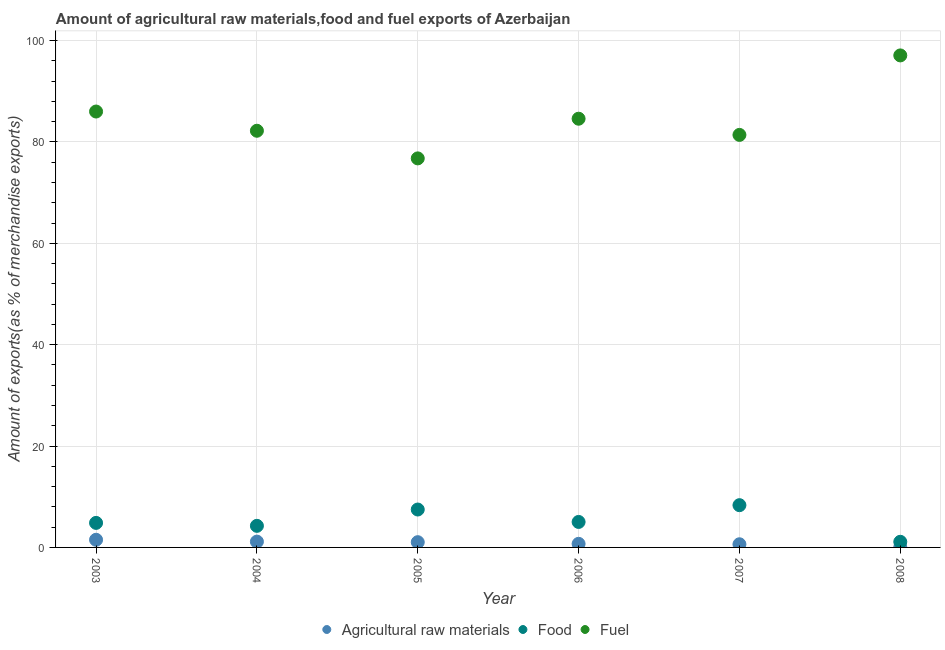Is the number of dotlines equal to the number of legend labels?
Make the answer very short. Yes. What is the percentage of raw materials exports in 2006?
Your answer should be compact. 0.71. Across all years, what is the maximum percentage of raw materials exports?
Keep it short and to the point. 1.51. Across all years, what is the minimum percentage of fuel exports?
Offer a very short reply. 76.76. In which year was the percentage of food exports maximum?
Your response must be concise. 2007. In which year was the percentage of raw materials exports minimum?
Your answer should be compact. 2008. What is the total percentage of fuel exports in the graph?
Give a very brief answer. 508.06. What is the difference between the percentage of fuel exports in 2003 and that in 2004?
Provide a short and direct response. 3.79. What is the difference between the percentage of food exports in 2007 and the percentage of fuel exports in 2008?
Your response must be concise. -88.75. What is the average percentage of food exports per year?
Your answer should be very brief. 5.18. In the year 2004, what is the difference between the percentage of fuel exports and percentage of food exports?
Your response must be concise. 77.96. In how many years, is the percentage of food exports greater than 40 %?
Make the answer very short. 0. What is the ratio of the percentage of raw materials exports in 2006 to that in 2008?
Keep it short and to the point. 16.55. Is the difference between the percentage of fuel exports in 2006 and 2008 greater than the difference between the percentage of raw materials exports in 2006 and 2008?
Offer a very short reply. No. What is the difference between the highest and the second highest percentage of raw materials exports?
Give a very brief answer. 0.36. What is the difference between the highest and the lowest percentage of food exports?
Ensure brevity in your answer.  7.23. Is the sum of the percentage of raw materials exports in 2004 and 2008 greater than the maximum percentage of food exports across all years?
Your answer should be compact. No. Is it the case that in every year, the sum of the percentage of raw materials exports and percentage of food exports is greater than the percentage of fuel exports?
Offer a terse response. No. Does the percentage of raw materials exports monotonically increase over the years?
Provide a short and direct response. No. Is the percentage of fuel exports strictly less than the percentage of food exports over the years?
Offer a terse response. No. How many dotlines are there?
Give a very brief answer. 3. How many years are there in the graph?
Your response must be concise. 6. Does the graph contain any zero values?
Give a very brief answer. No. How are the legend labels stacked?
Ensure brevity in your answer.  Horizontal. What is the title of the graph?
Provide a short and direct response. Amount of agricultural raw materials,food and fuel exports of Azerbaijan. Does "Refusal of sex" appear as one of the legend labels in the graph?
Your response must be concise. No. What is the label or title of the Y-axis?
Provide a succinct answer. Amount of exports(as % of merchandise exports). What is the Amount of exports(as % of merchandise exports) of Agricultural raw materials in 2003?
Offer a very short reply. 1.51. What is the Amount of exports(as % of merchandise exports) of Food in 2003?
Your response must be concise. 4.84. What is the Amount of exports(as % of merchandise exports) in Fuel in 2003?
Offer a very short reply. 86.01. What is the Amount of exports(as % of merchandise exports) in Agricultural raw materials in 2004?
Provide a succinct answer. 1.15. What is the Amount of exports(as % of merchandise exports) of Food in 2004?
Ensure brevity in your answer.  4.26. What is the Amount of exports(as % of merchandise exports) in Fuel in 2004?
Offer a terse response. 82.22. What is the Amount of exports(as % of merchandise exports) in Agricultural raw materials in 2005?
Your answer should be very brief. 1.03. What is the Amount of exports(as % of merchandise exports) in Food in 2005?
Offer a very short reply. 7.48. What is the Amount of exports(as % of merchandise exports) of Fuel in 2005?
Offer a terse response. 76.76. What is the Amount of exports(as % of merchandise exports) of Agricultural raw materials in 2006?
Your response must be concise. 0.71. What is the Amount of exports(as % of merchandise exports) in Food in 2006?
Your answer should be very brief. 5.03. What is the Amount of exports(as % of merchandise exports) in Fuel in 2006?
Your response must be concise. 84.59. What is the Amount of exports(as % of merchandise exports) of Agricultural raw materials in 2007?
Your answer should be compact. 0.62. What is the Amount of exports(as % of merchandise exports) in Food in 2007?
Provide a short and direct response. 8.34. What is the Amount of exports(as % of merchandise exports) in Fuel in 2007?
Keep it short and to the point. 81.4. What is the Amount of exports(as % of merchandise exports) of Agricultural raw materials in 2008?
Your answer should be very brief. 0.04. What is the Amount of exports(as % of merchandise exports) in Food in 2008?
Your response must be concise. 1.11. What is the Amount of exports(as % of merchandise exports) of Fuel in 2008?
Offer a terse response. 97.08. Across all years, what is the maximum Amount of exports(as % of merchandise exports) in Agricultural raw materials?
Offer a terse response. 1.51. Across all years, what is the maximum Amount of exports(as % of merchandise exports) in Food?
Make the answer very short. 8.34. Across all years, what is the maximum Amount of exports(as % of merchandise exports) in Fuel?
Provide a succinct answer. 97.08. Across all years, what is the minimum Amount of exports(as % of merchandise exports) of Agricultural raw materials?
Your response must be concise. 0.04. Across all years, what is the minimum Amount of exports(as % of merchandise exports) in Food?
Offer a terse response. 1.11. Across all years, what is the minimum Amount of exports(as % of merchandise exports) of Fuel?
Your answer should be compact. 76.76. What is the total Amount of exports(as % of merchandise exports) of Agricultural raw materials in the graph?
Provide a succinct answer. 5.06. What is the total Amount of exports(as % of merchandise exports) in Food in the graph?
Provide a succinct answer. 31.06. What is the total Amount of exports(as % of merchandise exports) in Fuel in the graph?
Make the answer very short. 508.06. What is the difference between the Amount of exports(as % of merchandise exports) of Agricultural raw materials in 2003 and that in 2004?
Your response must be concise. 0.36. What is the difference between the Amount of exports(as % of merchandise exports) of Food in 2003 and that in 2004?
Offer a very short reply. 0.58. What is the difference between the Amount of exports(as % of merchandise exports) in Fuel in 2003 and that in 2004?
Offer a very short reply. 3.79. What is the difference between the Amount of exports(as % of merchandise exports) in Agricultural raw materials in 2003 and that in 2005?
Keep it short and to the point. 0.48. What is the difference between the Amount of exports(as % of merchandise exports) of Food in 2003 and that in 2005?
Provide a short and direct response. -2.64. What is the difference between the Amount of exports(as % of merchandise exports) of Fuel in 2003 and that in 2005?
Provide a succinct answer. 9.25. What is the difference between the Amount of exports(as % of merchandise exports) in Agricultural raw materials in 2003 and that in 2006?
Your response must be concise. 0.8. What is the difference between the Amount of exports(as % of merchandise exports) of Food in 2003 and that in 2006?
Offer a very short reply. -0.19. What is the difference between the Amount of exports(as % of merchandise exports) in Fuel in 2003 and that in 2006?
Offer a very short reply. 1.42. What is the difference between the Amount of exports(as % of merchandise exports) in Agricultural raw materials in 2003 and that in 2007?
Your response must be concise. 0.89. What is the difference between the Amount of exports(as % of merchandise exports) of Food in 2003 and that in 2007?
Ensure brevity in your answer.  -3.5. What is the difference between the Amount of exports(as % of merchandise exports) in Fuel in 2003 and that in 2007?
Offer a terse response. 4.61. What is the difference between the Amount of exports(as % of merchandise exports) in Agricultural raw materials in 2003 and that in 2008?
Provide a short and direct response. 1.47. What is the difference between the Amount of exports(as % of merchandise exports) of Food in 2003 and that in 2008?
Provide a short and direct response. 3.73. What is the difference between the Amount of exports(as % of merchandise exports) in Fuel in 2003 and that in 2008?
Provide a succinct answer. -11.07. What is the difference between the Amount of exports(as % of merchandise exports) of Agricultural raw materials in 2004 and that in 2005?
Give a very brief answer. 0.11. What is the difference between the Amount of exports(as % of merchandise exports) of Food in 2004 and that in 2005?
Provide a short and direct response. -3.22. What is the difference between the Amount of exports(as % of merchandise exports) of Fuel in 2004 and that in 2005?
Offer a very short reply. 5.45. What is the difference between the Amount of exports(as % of merchandise exports) in Agricultural raw materials in 2004 and that in 2006?
Your answer should be compact. 0.44. What is the difference between the Amount of exports(as % of merchandise exports) in Food in 2004 and that in 2006?
Provide a succinct answer. -0.77. What is the difference between the Amount of exports(as % of merchandise exports) in Fuel in 2004 and that in 2006?
Your response must be concise. -2.38. What is the difference between the Amount of exports(as % of merchandise exports) of Agricultural raw materials in 2004 and that in 2007?
Your answer should be very brief. 0.52. What is the difference between the Amount of exports(as % of merchandise exports) of Food in 2004 and that in 2007?
Provide a succinct answer. -4.08. What is the difference between the Amount of exports(as % of merchandise exports) in Fuel in 2004 and that in 2007?
Provide a short and direct response. 0.82. What is the difference between the Amount of exports(as % of merchandise exports) in Agricultural raw materials in 2004 and that in 2008?
Your answer should be very brief. 1.1. What is the difference between the Amount of exports(as % of merchandise exports) of Food in 2004 and that in 2008?
Provide a short and direct response. 3.15. What is the difference between the Amount of exports(as % of merchandise exports) in Fuel in 2004 and that in 2008?
Your answer should be compact. -14.87. What is the difference between the Amount of exports(as % of merchandise exports) in Agricultural raw materials in 2005 and that in 2006?
Offer a terse response. 0.33. What is the difference between the Amount of exports(as % of merchandise exports) of Food in 2005 and that in 2006?
Your answer should be very brief. 2.45. What is the difference between the Amount of exports(as % of merchandise exports) in Fuel in 2005 and that in 2006?
Offer a terse response. -7.83. What is the difference between the Amount of exports(as % of merchandise exports) of Agricultural raw materials in 2005 and that in 2007?
Keep it short and to the point. 0.41. What is the difference between the Amount of exports(as % of merchandise exports) in Food in 2005 and that in 2007?
Provide a succinct answer. -0.86. What is the difference between the Amount of exports(as % of merchandise exports) of Fuel in 2005 and that in 2007?
Give a very brief answer. -4.63. What is the difference between the Amount of exports(as % of merchandise exports) of Agricultural raw materials in 2005 and that in 2008?
Provide a succinct answer. 0.99. What is the difference between the Amount of exports(as % of merchandise exports) in Food in 2005 and that in 2008?
Give a very brief answer. 6.37. What is the difference between the Amount of exports(as % of merchandise exports) of Fuel in 2005 and that in 2008?
Provide a succinct answer. -20.32. What is the difference between the Amount of exports(as % of merchandise exports) in Agricultural raw materials in 2006 and that in 2007?
Provide a short and direct response. 0.08. What is the difference between the Amount of exports(as % of merchandise exports) in Food in 2006 and that in 2007?
Ensure brevity in your answer.  -3.31. What is the difference between the Amount of exports(as % of merchandise exports) of Fuel in 2006 and that in 2007?
Your response must be concise. 3.19. What is the difference between the Amount of exports(as % of merchandise exports) in Agricultural raw materials in 2006 and that in 2008?
Offer a terse response. 0.66. What is the difference between the Amount of exports(as % of merchandise exports) of Food in 2006 and that in 2008?
Your response must be concise. 3.92. What is the difference between the Amount of exports(as % of merchandise exports) of Fuel in 2006 and that in 2008?
Keep it short and to the point. -12.49. What is the difference between the Amount of exports(as % of merchandise exports) of Agricultural raw materials in 2007 and that in 2008?
Your answer should be compact. 0.58. What is the difference between the Amount of exports(as % of merchandise exports) of Food in 2007 and that in 2008?
Your response must be concise. 7.23. What is the difference between the Amount of exports(as % of merchandise exports) in Fuel in 2007 and that in 2008?
Provide a succinct answer. -15.68. What is the difference between the Amount of exports(as % of merchandise exports) in Agricultural raw materials in 2003 and the Amount of exports(as % of merchandise exports) in Food in 2004?
Provide a short and direct response. -2.75. What is the difference between the Amount of exports(as % of merchandise exports) of Agricultural raw materials in 2003 and the Amount of exports(as % of merchandise exports) of Fuel in 2004?
Give a very brief answer. -80.71. What is the difference between the Amount of exports(as % of merchandise exports) in Food in 2003 and the Amount of exports(as % of merchandise exports) in Fuel in 2004?
Your answer should be compact. -77.38. What is the difference between the Amount of exports(as % of merchandise exports) in Agricultural raw materials in 2003 and the Amount of exports(as % of merchandise exports) in Food in 2005?
Your answer should be compact. -5.97. What is the difference between the Amount of exports(as % of merchandise exports) of Agricultural raw materials in 2003 and the Amount of exports(as % of merchandise exports) of Fuel in 2005?
Your answer should be very brief. -75.26. What is the difference between the Amount of exports(as % of merchandise exports) in Food in 2003 and the Amount of exports(as % of merchandise exports) in Fuel in 2005?
Give a very brief answer. -71.92. What is the difference between the Amount of exports(as % of merchandise exports) in Agricultural raw materials in 2003 and the Amount of exports(as % of merchandise exports) in Food in 2006?
Your answer should be very brief. -3.52. What is the difference between the Amount of exports(as % of merchandise exports) of Agricultural raw materials in 2003 and the Amount of exports(as % of merchandise exports) of Fuel in 2006?
Ensure brevity in your answer.  -83.08. What is the difference between the Amount of exports(as % of merchandise exports) of Food in 2003 and the Amount of exports(as % of merchandise exports) of Fuel in 2006?
Your answer should be compact. -79.75. What is the difference between the Amount of exports(as % of merchandise exports) of Agricultural raw materials in 2003 and the Amount of exports(as % of merchandise exports) of Food in 2007?
Keep it short and to the point. -6.83. What is the difference between the Amount of exports(as % of merchandise exports) of Agricultural raw materials in 2003 and the Amount of exports(as % of merchandise exports) of Fuel in 2007?
Provide a succinct answer. -79.89. What is the difference between the Amount of exports(as % of merchandise exports) in Food in 2003 and the Amount of exports(as % of merchandise exports) in Fuel in 2007?
Offer a terse response. -76.56. What is the difference between the Amount of exports(as % of merchandise exports) of Agricultural raw materials in 2003 and the Amount of exports(as % of merchandise exports) of Food in 2008?
Ensure brevity in your answer.  0.4. What is the difference between the Amount of exports(as % of merchandise exports) of Agricultural raw materials in 2003 and the Amount of exports(as % of merchandise exports) of Fuel in 2008?
Keep it short and to the point. -95.57. What is the difference between the Amount of exports(as % of merchandise exports) of Food in 2003 and the Amount of exports(as % of merchandise exports) of Fuel in 2008?
Your response must be concise. -92.24. What is the difference between the Amount of exports(as % of merchandise exports) in Agricultural raw materials in 2004 and the Amount of exports(as % of merchandise exports) in Food in 2005?
Your answer should be compact. -6.33. What is the difference between the Amount of exports(as % of merchandise exports) of Agricultural raw materials in 2004 and the Amount of exports(as % of merchandise exports) of Fuel in 2005?
Your answer should be very brief. -75.62. What is the difference between the Amount of exports(as % of merchandise exports) of Food in 2004 and the Amount of exports(as % of merchandise exports) of Fuel in 2005?
Your response must be concise. -72.51. What is the difference between the Amount of exports(as % of merchandise exports) of Agricultural raw materials in 2004 and the Amount of exports(as % of merchandise exports) of Food in 2006?
Your answer should be compact. -3.88. What is the difference between the Amount of exports(as % of merchandise exports) in Agricultural raw materials in 2004 and the Amount of exports(as % of merchandise exports) in Fuel in 2006?
Keep it short and to the point. -83.45. What is the difference between the Amount of exports(as % of merchandise exports) of Food in 2004 and the Amount of exports(as % of merchandise exports) of Fuel in 2006?
Your response must be concise. -80.33. What is the difference between the Amount of exports(as % of merchandise exports) of Agricultural raw materials in 2004 and the Amount of exports(as % of merchandise exports) of Food in 2007?
Your answer should be very brief. -7.19. What is the difference between the Amount of exports(as % of merchandise exports) in Agricultural raw materials in 2004 and the Amount of exports(as % of merchandise exports) in Fuel in 2007?
Your answer should be compact. -80.25. What is the difference between the Amount of exports(as % of merchandise exports) of Food in 2004 and the Amount of exports(as % of merchandise exports) of Fuel in 2007?
Ensure brevity in your answer.  -77.14. What is the difference between the Amount of exports(as % of merchandise exports) in Agricultural raw materials in 2004 and the Amount of exports(as % of merchandise exports) in Food in 2008?
Your answer should be compact. 0.03. What is the difference between the Amount of exports(as % of merchandise exports) of Agricultural raw materials in 2004 and the Amount of exports(as % of merchandise exports) of Fuel in 2008?
Provide a short and direct response. -95.94. What is the difference between the Amount of exports(as % of merchandise exports) of Food in 2004 and the Amount of exports(as % of merchandise exports) of Fuel in 2008?
Provide a short and direct response. -92.82. What is the difference between the Amount of exports(as % of merchandise exports) of Agricultural raw materials in 2005 and the Amount of exports(as % of merchandise exports) of Food in 2006?
Offer a very short reply. -4. What is the difference between the Amount of exports(as % of merchandise exports) of Agricultural raw materials in 2005 and the Amount of exports(as % of merchandise exports) of Fuel in 2006?
Your answer should be very brief. -83.56. What is the difference between the Amount of exports(as % of merchandise exports) of Food in 2005 and the Amount of exports(as % of merchandise exports) of Fuel in 2006?
Provide a succinct answer. -77.11. What is the difference between the Amount of exports(as % of merchandise exports) in Agricultural raw materials in 2005 and the Amount of exports(as % of merchandise exports) in Food in 2007?
Make the answer very short. -7.3. What is the difference between the Amount of exports(as % of merchandise exports) of Agricultural raw materials in 2005 and the Amount of exports(as % of merchandise exports) of Fuel in 2007?
Your response must be concise. -80.37. What is the difference between the Amount of exports(as % of merchandise exports) in Food in 2005 and the Amount of exports(as % of merchandise exports) in Fuel in 2007?
Provide a succinct answer. -73.92. What is the difference between the Amount of exports(as % of merchandise exports) of Agricultural raw materials in 2005 and the Amount of exports(as % of merchandise exports) of Food in 2008?
Your response must be concise. -0.08. What is the difference between the Amount of exports(as % of merchandise exports) of Agricultural raw materials in 2005 and the Amount of exports(as % of merchandise exports) of Fuel in 2008?
Give a very brief answer. -96.05. What is the difference between the Amount of exports(as % of merchandise exports) of Food in 2005 and the Amount of exports(as % of merchandise exports) of Fuel in 2008?
Keep it short and to the point. -89.6. What is the difference between the Amount of exports(as % of merchandise exports) of Agricultural raw materials in 2006 and the Amount of exports(as % of merchandise exports) of Food in 2007?
Your answer should be very brief. -7.63. What is the difference between the Amount of exports(as % of merchandise exports) of Agricultural raw materials in 2006 and the Amount of exports(as % of merchandise exports) of Fuel in 2007?
Your answer should be compact. -80.69. What is the difference between the Amount of exports(as % of merchandise exports) in Food in 2006 and the Amount of exports(as % of merchandise exports) in Fuel in 2007?
Your answer should be very brief. -76.37. What is the difference between the Amount of exports(as % of merchandise exports) in Agricultural raw materials in 2006 and the Amount of exports(as % of merchandise exports) in Food in 2008?
Provide a succinct answer. -0.4. What is the difference between the Amount of exports(as % of merchandise exports) in Agricultural raw materials in 2006 and the Amount of exports(as % of merchandise exports) in Fuel in 2008?
Offer a terse response. -96.38. What is the difference between the Amount of exports(as % of merchandise exports) in Food in 2006 and the Amount of exports(as % of merchandise exports) in Fuel in 2008?
Provide a short and direct response. -92.05. What is the difference between the Amount of exports(as % of merchandise exports) in Agricultural raw materials in 2007 and the Amount of exports(as % of merchandise exports) in Food in 2008?
Provide a succinct answer. -0.49. What is the difference between the Amount of exports(as % of merchandise exports) of Agricultural raw materials in 2007 and the Amount of exports(as % of merchandise exports) of Fuel in 2008?
Offer a very short reply. -96.46. What is the difference between the Amount of exports(as % of merchandise exports) of Food in 2007 and the Amount of exports(as % of merchandise exports) of Fuel in 2008?
Make the answer very short. -88.75. What is the average Amount of exports(as % of merchandise exports) of Agricultural raw materials per year?
Give a very brief answer. 0.84. What is the average Amount of exports(as % of merchandise exports) in Food per year?
Keep it short and to the point. 5.18. What is the average Amount of exports(as % of merchandise exports) in Fuel per year?
Ensure brevity in your answer.  84.68. In the year 2003, what is the difference between the Amount of exports(as % of merchandise exports) in Agricultural raw materials and Amount of exports(as % of merchandise exports) in Food?
Make the answer very short. -3.33. In the year 2003, what is the difference between the Amount of exports(as % of merchandise exports) of Agricultural raw materials and Amount of exports(as % of merchandise exports) of Fuel?
Your response must be concise. -84.5. In the year 2003, what is the difference between the Amount of exports(as % of merchandise exports) of Food and Amount of exports(as % of merchandise exports) of Fuel?
Your answer should be compact. -81.17. In the year 2004, what is the difference between the Amount of exports(as % of merchandise exports) of Agricultural raw materials and Amount of exports(as % of merchandise exports) of Food?
Your response must be concise. -3.11. In the year 2004, what is the difference between the Amount of exports(as % of merchandise exports) in Agricultural raw materials and Amount of exports(as % of merchandise exports) in Fuel?
Provide a succinct answer. -81.07. In the year 2004, what is the difference between the Amount of exports(as % of merchandise exports) in Food and Amount of exports(as % of merchandise exports) in Fuel?
Keep it short and to the point. -77.96. In the year 2005, what is the difference between the Amount of exports(as % of merchandise exports) of Agricultural raw materials and Amount of exports(as % of merchandise exports) of Food?
Offer a very short reply. -6.45. In the year 2005, what is the difference between the Amount of exports(as % of merchandise exports) in Agricultural raw materials and Amount of exports(as % of merchandise exports) in Fuel?
Ensure brevity in your answer.  -75.73. In the year 2005, what is the difference between the Amount of exports(as % of merchandise exports) in Food and Amount of exports(as % of merchandise exports) in Fuel?
Keep it short and to the point. -69.29. In the year 2006, what is the difference between the Amount of exports(as % of merchandise exports) of Agricultural raw materials and Amount of exports(as % of merchandise exports) of Food?
Provide a succinct answer. -4.32. In the year 2006, what is the difference between the Amount of exports(as % of merchandise exports) of Agricultural raw materials and Amount of exports(as % of merchandise exports) of Fuel?
Offer a very short reply. -83.88. In the year 2006, what is the difference between the Amount of exports(as % of merchandise exports) of Food and Amount of exports(as % of merchandise exports) of Fuel?
Provide a succinct answer. -79.56. In the year 2007, what is the difference between the Amount of exports(as % of merchandise exports) in Agricultural raw materials and Amount of exports(as % of merchandise exports) in Food?
Your answer should be very brief. -7.71. In the year 2007, what is the difference between the Amount of exports(as % of merchandise exports) in Agricultural raw materials and Amount of exports(as % of merchandise exports) in Fuel?
Provide a succinct answer. -80.78. In the year 2007, what is the difference between the Amount of exports(as % of merchandise exports) of Food and Amount of exports(as % of merchandise exports) of Fuel?
Provide a short and direct response. -73.06. In the year 2008, what is the difference between the Amount of exports(as % of merchandise exports) of Agricultural raw materials and Amount of exports(as % of merchandise exports) of Food?
Keep it short and to the point. -1.07. In the year 2008, what is the difference between the Amount of exports(as % of merchandise exports) in Agricultural raw materials and Amount of exports(as % of merchandise exports) in Fuel?
Offer a very short reply. -97.04. In the year 2008, what is the difference between the Amount of exports(as % of merchandise exports) of Food and Amount of exports(as % of merchandise exports) of Fuel?
Offer a very short reply. -95.97. What is the ratio of the Amount of exports(as % of merchandise exports) in Agricultural raw materials in 2003 to that in 2004?
Your response must be concise. 1.32. What is the ratio of the Amount of exports(as % of merchandise exports) in Food in 2003 to that in 2004?
Your answer should be compact. 1.14. What is the ratio of the Amount of exports(as % of merchandise exports) in Fuel in 2003 to that in 2004?
Ensure brevity in your answer.  1.05. What is the ratio of the Amount of exports(as % of merchandise exports) in Agricultural raw materials in 2003 to that in 2005?
Ensure brevity in your answer.  1.46. What is the ratio of the Amount of exports(as % of merchandise exports) of Food in 2003 to that in 2005?
Your response must be concise. 0.65. What is the ratio of the Amount of exports(as % of merchandise exports) of Fuel in 2003 to that in 2005?
Offer a very short reply. 1.12. What is the ratio of the Amount of exports(as % of merchandise exports) of Agricultural raw materials in 2003 to that in 2006?
Make the answer very short. 2.13. What is the ratio of the Amount of exports(as % of merchandise exports) in Food in 2003 to that in 2006?
Provide a succinct answer. 0.96. What is the ratio of the Amount of exports(as % of merchandise exports) of Fuel in 2003 to that in 2006?
Ensure brevity in your answer.  1.02. What is the ratio of the Amount of exports(as % of merchandise exports) of Agricultural raw materials in 2003 to that in 2007?
Give a very brief answer. 2.42. What is the ratio of the Amount of exports(as % of merchandise exports) of Food in 2003 to that in 2007?
Offer a very short reply. 0.58. What is the ratio of the Amount of exports(as % of merchandise exports) of Fuel in 2003 to that in 2007?
Make the answer very short. 1.06. What is the ratio of the Amount of exports(as % of merchandise exports) of Agricultural raw materials in 2003 to that in 2008?
Make the answer very short. 35.32. What is the ratio of the Amount of exports(as % of merchandise exports) in Food in 2003 to that in 2008?
Your answer should be very brief. 4.36. What is the ratio of the Amount of exports(as % of merchandise exports) in Fuel in 2003 to that in 2008?
Provide a succinct answer. 0.89. What is the ratio of the Amount of exports(as % of merchandise exports) of Agricultural raw materials in 2004 to that in 2005?
Provide a short and direct response. 1.11. What is the ratio of the Amount of exports(as % of merchandise exports) in Food in 2004 to that in 2005?
Provide a succinct answer. 0.57. What is the ratio of the Amount of exports(as % of merchandise exports) in Fuel in 2004 to that in 2005?
Ensure brevity in your answer.  1.07. What is the ratio of the Amount of exports(as % of merchandise exports) in Agricultural raw materials in 2004 to that in 2006?
Provide a succinct answer. 1.62. What is the ratio of the Amount of exports(as % of merchandise exports) of Food in 2004 to that in 2006?
Your response must be concise. 0.85. What is the ratio of the Amount of exports(as % of merchandise exports) in Fuel in 2004 to that in 2006?
Provide a succinct answer. 0.97. What is the ratio of the Amount of exports(as % of merchandise exports) of Agricultural raw materials in 2004 to that in 2007?
Give a very brief answer. 1.84. What is the ratio of the Amount of exports(as % of merchandise exports) of Food in 2004 to that in 2007?
Your answer should be very brief. 0.51. What is the ratio of the Amount of exports(as % of merchandise exports) in Fuel in 2004 to that in 2007?
Keep it short and to the point. 1.01. What is the ratio of the Amount of exports(as % of merchandise exports) in Agricultural raw materials in 2004 to that in 2008?
Give a very brief answer. 26.8. What is the ratio of the Amount of exports(as % of merchandise exports) of Food in 2004 to that in 2008?
Ensure brevity in your answer.  3.83. What is the ratio of the Amount of exports(as % of merchandise exports) in Fuel in 2004 to that in 2008?
Your response must be concise. 0.85. What is the ratio of the Amount of exports(as % of merchandise exports) in Agricultural raw materials in 2005 to that in 2006?
Your response must be concise. 1.46. What is the ratio of the Amount of exports(as % of merchandise exports) of Food in 2005 to that in 2006?
Provide a succinct answer. 1.49. What is the ratio of the Amount of exports(as % of merchandise exports) in Fuel in 2005 to that in 2006?
Your answer should be very brief. 0.91. What is the ratio of the Amount of exports(as % of merchandise exports) in Agricultural raw materials in 2005 to that in 2007?
Make the answer very short. 1.66. What is the ratio of the Amount of exports(as % of merchandise exports) in Food in 2005 to that in 2007?
Ensure brevity in your answer.  0.9. What is the ratio of the Amount of exports(as % of merchandise exports) of Fuel in 2005 to that in 2007?
Make the answer very short. 0.94. What is the ratio of the Amount of exports(as % of merchandise exports) of Agricultural raw materials in 2005 to that in 2008?
Your response must be concise. 24.19. What is the ratio of the Amount of exports(as % of merchandise exports) of Food in 2005 to that in 2008?
Your answer should be compact. 6.73. What is the ratio of the Amount of exports(as % of merchandise exports) of Fuel in 2005 to that in 2008?
Give a very brief answer. 0.79. What is the ratio of the Amount of exports(as % of merchandise exports) of Agricultural raw materials in 2006 to that in 2007?
Your response must be concise. 1.13. What is the ratio of the Amount of exports(as % of merchandise exports) in Food in 2006 to that in 2007?
Your answer should be compact. 0.6. What is the ratio of the Amount of exports(as % of merchandise exports) of Fuel in 2006 to that in 2007?
Ensure brevity in your answer.  1.04. What is the ratio of the Amount of exports(as % of merchandise exports) of Agricultural raw materials in 2006 to that in 2008?
Offer a very short reply. 16.55. What is the ratio of the Amount of exports(as % of merchandise exports) in Food in 2006 to that in 2008?
Keep it short and to the point. 4.53. What is the ratio of the Amount of exports(as % of merchandise exports) of Fuel in 2006 to that in 2008?
Ensure brevity in your answer.  0.87. What is the ratio of the Amount of exports(as % of merchandise exports) in Agricultural raw materials in 2007 to that in 2008?
Provide a short and direct response. 14.58. What is the ratio of the Amount of exports(as % of merchandise exports) in Food in 2007 to that in 2008?
Provide a succinct answer. 7.5. What is the ratio of the Amount of exports(as % of merchandise exports) of Fuel in 2007 to that in 2008?
Give a very brief answer. 0.84. What is the difference between the highest and the second highest Amount of exports(as % of merchandise exports) in Agricultural raw materials?
Offer a very short reply. 0.36. What is the difference between the highest and the second highest Amount of exports(as % of merchandise exports) in Food?
Provide a succinct answer. 0.86. What is the difference between the highest and the second highest Amount of exports(as % of merchandise exports) in Fuel?
Your response must be concise. 11.07. What is the difference between the highest and the lowest Amount of exports(as % of merchandise exports) of Agricultural raw materials?
Offer a terse response. 1.47. What is the difference between the highest and the lowest Amount of exports(as % of merchandise exports) of Food?
Ensure brevity in your answer.  7.23. What is the difference between the highest and the lowest Amount of exports(as % of merchandise exports) in Fuel?
Your answer should be very brief. 20.32. 